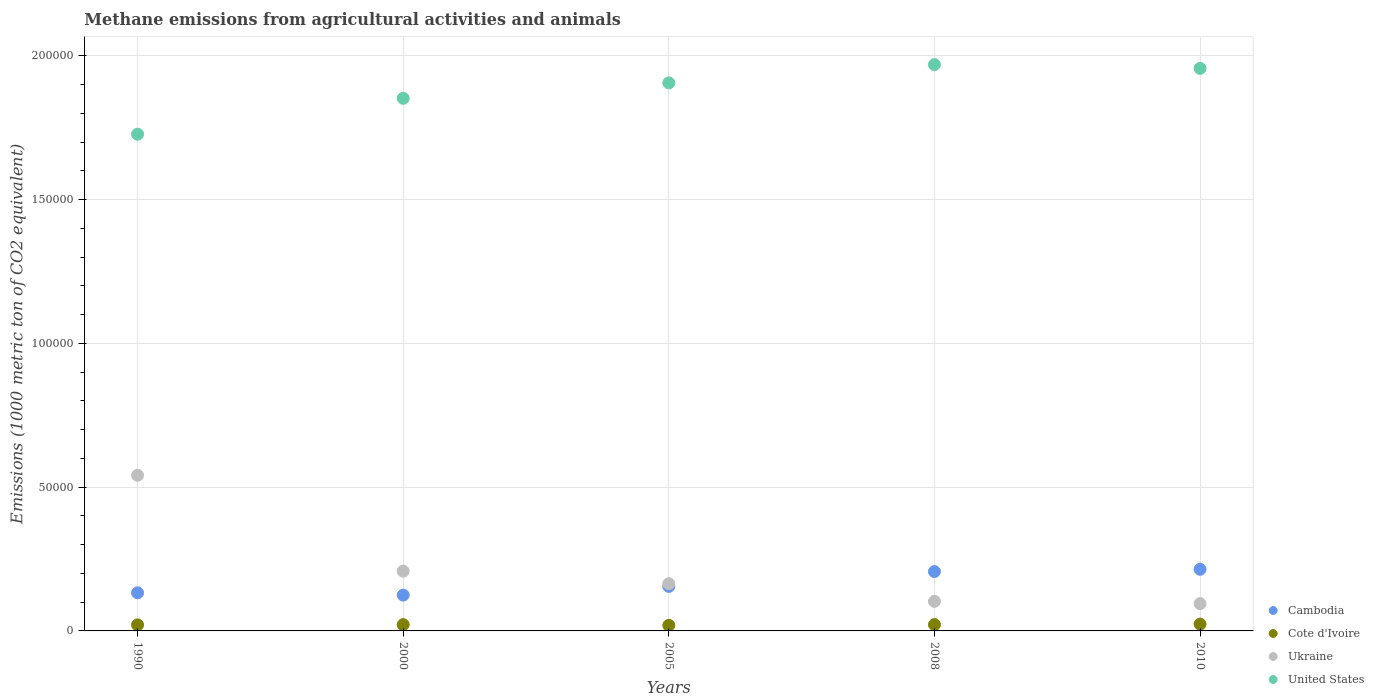How many different coloured dotlines are there?
Provide a succinct answer. 4. What is the amount of methane emitted in United States in 2005?
Your answer should be compact. 1.91e+05. Across all years, what is the maximum amount of methane emitted in Cote d'Ivoire?
Your answer should be compact. 2375.2. Across all years, what is the minimum amount of methane emitted in United States?
Provide a short and direct response. 1.73e+05. In which year was the amount of methane emitted in United States maximum?
Your answer should be compact. 2008. What is the total amount of methane emitted in United States in the graph?
Your answer should be very brief. 9.41e+05. What is the difference between the amount of methane emitted in Cambodia in 1990 and that in 2010?
Your answer should be compact. -8182.5. What is the difference between the amount of methane emitted in United States in 1990 and the amount of methane emitted in Cote d'Ivoire in 2010?
Your response must be concise. 1.70e+05. What is the average amount of methane emitted in Ukraine per year?
Keep it short and to the point. 2.22e+04. In the year 1990, what is the difference between the amount of methane emitted in Ukraine and amount of methane emitted in Cote d'Ivoire?
Make the answer very short. 5.20e+04. What is the ratio of the amount of methane emitted in Ukraine in 2000 to that in 2008?
Offer a terse response. 2.02. Is the amount of methane emitted in Cambodia in 2005 less than that in 2008?
Provide a succinct answer. Yes. What is the difference between the highest and the second highest amount of methane emitted in Cote d'Ivoire?
Keep it short and to the point. 184.9. What is the difference between the highest and the lowest amount of methane emitted in Cote d'Ivoire?
Offer a terse response. 425.1. In how many years, is the amount of methane emitted in Cambodia greater than the average amount of methane emitted in Cambodia taken over all years?
Your response must be concise. 2. Is the sum of the amount of methane emitted in Ukraine in 2008 and 2010 greater than the maximum amount of methane emitted in Cote d'Ivoire across all years?
Your answer should be very brief. Yes. Is it the case that in every year, the sum of the amount of methane emitted in Ukraine and amount of methane emitted in Cambodia  is greater than the sum of amount of methane emitted in Cote d'Ivoire and amount of methane emitted in United States?
Give a very brief answer. Yes. Is it the case that in every year, the sum of the amount of methane emitted in Cote d'Ivoire and amount of methane emitted in United States  is greater than the amount of methane emitted in Cambodia?
Your answer should be compact. Yes. Does the amount of methane emitted in United States monotonically increase over the years?
Provide a succinct answer. No. Is the amount of methane emitted in Cambodia strictly less than the amount of methane emitted in Ukraine over the years?
Your answer should be very brief. No. How many years are there in the graph?
Offer a terse response. 5. Are the values on the major ticks of Y-axis written in scientific E-notation?
Your answer should be very brief. No. Does the graph contain any zero values?
Your answer should be compact. No. Does the graph contain grids?
Your response must be concise. Yes. Where does the legend appear in the graph?
Offer a terse response. Bottom right. How many legend labels are there?
Make the answer very short. 4. How are the legend labels stacked?
Offer a very short reply. Vertical. What is the title of the graph?
Your answer should be compact. Methane emissions from agricultural activities and animals. What is the label or title of the X-axis?
Offer a terse response. Years. What is the label or title of the Y-axis?
Keep it short and to the point. Emissions (1000 metric ton of CO2 equivalent). What is the Emissions (1000 metric ton of CO2 equivalent) in Cambodia in 1990?
Provide a short and direct response. 1.32e+04. What is the Emissions (1000 metric ton of CO2 equivalent) of Cote d'Ivoire in 1990?
Offer a very short reply. 2104. What is the Emissions (1000 metric ton of CO2 equivalent) in Ukraine in 1990?
Ensure brevity in your answer.  5.41e+04. What is the Emissions (1000 metric ton of CO2 equivalent) of United States in 1990?
Your answer should be compact. 1.73e+05. What is the Emissions (1000 metric ton of CO2 equivalent) of Cambodia in 2000?
Offer a terse response. 1.25e+04. What is the Emissions (1000 metric ton of CO2 equivalent) of Cote d'Ivoire in 2000?
Give a very brief answer. 2183.1. What is the Emissions (1000 metric ton of CO2 equivalent) in Ukraine in 2000?
Provide a succinct answer. 2.08e+04. What is the Emissions (1000 metric ton of CO2 equivalent) of United States in 2000?
Provide a succinct answer. 1.85e+05. What is the Emissions (1000 metric ton of CO2 equivalent) of Cambodia in 2005?
Offer a very short reply. 1.55e+04. What is the Emissions (1000 metric ton of CO2 equivalent) in Cote d'Ivoire in 2005?
Ensure brevity in your answer.  1950.1. What is the Emissions (1000 metric ton of CO2 equivalent) in Ukraine in 2005?
Make the answer very short. 1.64e+04. What is the Emissions (1000 metric ton of CO2 equivalent) in United States in 2005?
Give a very brief answer. 1.91e+05. What is the Emissions (1000 metric ton of CO2 equivalent) in Cambodia in 2008?
Ensure brevity in your answer.  2.06e+04. What is the Emissions (1000 metric ton of CO2 equivalent) in Cote d'Ivoire in 2008?
Ensure brevity in your answer.  2190.3. What is the Emissions (1000 metric ton of CO2 equivalent) of Ukraine in 2008?
Give a very brief answer. 1.03e+04. What is the Emissions (1000 metric ton of CO2 equivalent) in United States in 2008?
Offer a very short reply. 1.97e+05. What is the Emissions (1000 metric ton of CO2 equivalent) of Cambodia in 2010?
Provide a succinct answer. 2.14e+04. What is the Emissions (1000 metric ton of CO2 equivalent) of Cote d'Ivoire in 2010?
Keep it short and to the point. 2375.2. What is the Emissions (1000 metric ton of CO2 equivalent) of Ukraine in 2010?
Give a very brief answer. 9489.8. What is the Emissions (1000 metric ton of CO2 equivalent) of United States in 2010?
Offer a very short reply. 1.96e+05. Across all years, what is the maximum Emissions (1000 metric ton of CO2 equivalent) of Cambodia?
Provide a succinct answer. 2.14e+04. Across all years, what is the maximum Emissions (1000 metric ton of CO2 equivalent) in Cote d'Ivoire?
Offer a very short reply. 2375.2. Across all years, what is the maximum Emissions (1000 metric ton of CO2 equivalent) of Ukraine?
Offer a very short reply. 5.41e+04. Across all years, what is the maximum Emissions (1000 metric ton of CO2 equivalent) of United States?
Offer a very short reply. 1.97e+05. Across all years, what is the minimum Emissions (1000 metric ton of CO2 equivalent) of Cambodia?
Your response must be concise. 1.25e+04. Across all years, what is the minimum Emissions (1000 metric ton of CO2 equivalent) in Cote d'Ivoire?
Make the answer very short. 1950.1. Across all years, what is the minimum Emissions (1000 metric ton of CO2 equivalent) of Ukraine?
Provide a succinct answer. 9489.8. Across all years, what is the minimum Emissions (1000 metric ton of CO2 equivalent) in United States?
Provide a short and direct response. 1.73e+05. What is the total Emissions (1000 metric ton of CO2 equivalent) in Cambodia in the graph?
Keep it short and to the point. 8.32e+04. What is the total Emissions (1000 metric ton of CO2 equivalent) in Cote d'Ivoire in the graph?
Offer a very short reply. 1.08e+04. What is the total Emissions (1000 metric ton of CO2 equivalent) of Ukraine in the graph?
Your response must be concise. 1.11e+05. What is the total Emissions (1000 metric ton of CO2 equivalent) of United States in the graph?
Give a very brief answer. 9.41e+05. What is the difference between the Emissions (1000 metric ton of CO2 equivalent) of Cambodia in 1990 and that in 2000?
Your response must be concise. 796.5. What is the difference between the Emissions (1000 metric ton of CO2 equivalent) in Cote d'Ivoire in 1990 and that in 2000?
Offer a very short reply. -79.1. What is the difference between the Emissions (1000 metric ton of CO2 equivalent) of Ukraine in 1990 and that in 2000?
Keep it short and to the point. 3.33e+04. What is the difference between the Emissions (1000 metric ton of CO2 equivalent) of United States in 1990 and that in 2000?
Your answer should be compact. -1.25e+04. What is the difference between the Emissions (1000 metric ton of CO2 equivalent) of Cambodia in 1990 and that in 2005?
Your answer should be very brief. -2227.1. What is the difference between the Emissions (1000 metric ton of CO2 equivalent) in Cote d'Ivoire in 1990 and that in 2005?
Your answer should be compact. 153.9. What is the difference between the Emissions (1000 metric ton of CO2 equivalent) of Ukraine in 1990 and that in 2005?
Offer a very short reply. 3.77e+04. What is the difference between the Emissions (1000 metric ton of CO2 equivalent) of United States in 1990 and that in 2005?
Provide a succinct answer. -1.78e+04. What is the difference between the Emissions (1000 metric ton of CO2 equivalent) of Cambodia in 1990 and that in 2008?
Give a very brief answer. -7382.4. What is the difference between the Emissions (1000 metric ton of CO2 equivalent) in Cote d'Ivoire in 1990 and that in 2008?
Keep it short and to the point. -86.3. What is the difference between the Emissions (1000 metric ton of CO2 equivalent) in Ukraine in 1990 and that in 2008?
Provide a short and direct response. 4.38e+04. What is the difference between the Emissions (1000 metric ton of CO2 equivalent) of United States in 1990 and that in 2008?
Offer a very short reply. -2.42e+04. What is the difference between the Emissions (1000 metric ton of CO2 equivalent) in Cambodia in 1990 and that in 2010?
Provide a succinct answer. -8182.5. What is the difference between the Emissions (1000 metric ton of CO2 equivalent) in Cote d'Ivoire in 1990 and that in 2010?
Keep it short and to the point. -271.2. What is the difference between the Emissions (1000 metric ton of CO2 equivalent) of Ukraine in 1990 and that in 2010?
Ensure brevity in your answer.  4.46e+04. What is the difference between the Emissions (1000 metric ton of CO2 equivalent) in United States in 1990 and that in 2010?
Offer a very short reply. -2.29e+04. What is the difference between the Emissions (1000 metric ton of CO2 equivalent) of Cambodia in 2000 and that in 2005?
Offer a very short reply. -3023.6. What is the difference between the Emissions (1000 metric ton of CO2 equivalent) in Cote d'Ivoire in 2000 and that in 2005?
Your answer should be compact. 233. What is the difference between the Emissions (1000 metric ton of CO2 equivalent) in Ukraine in 2000 and that in 2005?
Your answer should be compact. 4372.1. What is the difference between the Emissions (1000 metric ton of CO2 equivalent) of United States in 2000 and that in 2005?
Your answer should be compact. -5362.7. What is the difference between the Emissions (1000 metric ton of CO2 equivalent) of Cambodia in 2000 and that in 2008?
Offer a very short reply. -8178.9. What is the difference between the Emissions (1000 metric ton of CO2 equivalent) of Cote d'Ivoire in 2000 and that in 2008?
Keep it short and to the point. -7.2. What is the difference between the Emissions (1000 metric ton of CO2 equivalent) of Ukraine in 2000 and that in 2008?
Your answer should be very brief. 1.05e+04. What is the difference between the Emissions (1000 metric ton of CO2 equivalent) in United States in 2000 and that in 2008?
Keep it short and to the point. -1.17e+04. What is the difference between the Emissions (1000 metric ton of CO2 equivalent) of Cambodia in 2000 and that in 2010?
Provide a short and direct response. -8979. What is the difference between the Emissions (1000 metric ton of CO2 equivalent) in Cote d'Ivoire in 2000 and that in 2010?
Your answer should be very brief. -192.1. What is the difference between the Emissions (1000 metric ton of CO2 equivalent) in Ukraine in 2000 and that in 2010?
Make the answer very short. 1.13e+04. What is the difference between the Emissions (1000 metric ton of CO2 equivalent) in United States in 2000 and that in 2010?
Your response must be concise. -1.04e+04. What is the difference between the Emissions (1000 metric ton of CO2 equivalent) of Cambodia in 2005 and that in 2008?
Your answer should be very brief. -5155.3. What is the difference between the Emissions (1000 metric ton of CO2 equivalent) in Cote d'Ivoire in 2005 and that in 2008?
Your answer should be very brief. -240.2. What is the difference between the Emissions (1000 metric ton of CO2 equivalent) of Ukraine in 2005 and that in 2008?
Your answer should be compact. 6133.4. What is the difference between the Emissions (1000 metric ton of CO2 equivalent) in United States in 2005 and that in 2008?
Your answer should be very brief. -6353.6. What is the difference between the Emissions (1000 metric ton of CO2 equivalent) in Cambodia in 2005 and that in 2010?
Provide a succinct answer. -5955.4. What is the difference between the Emissions (1000 metric ton of CO2 equivalent) of Cote d'Ivoire in 2005 and that in 2010?
Give a very brief answer. -425.1. What is the difference between the Emissions (1000 metric ton of CO2 equivalent) of Ukraine in 2005 and that in 2010?
Your answer should be compact. 6921.6. What is the difference between the Emissions (1000 metric ton of CO2 equivalent) of United States in 2005 and that in 2010?
Your answer should be very brief. -5038.6. What is the difference between the Emissions (1000 metric ton of CO2 equivalent) in Cambodia in 2008 and that in 2010?
Make the answer very short. -800.1. What is the difference between the Emissions (1000 metric ton of CO2 equivalent) of Cote d'Ivoire in 2008 and that in 2010?
Ensure brevity in your answer.  -184.9. What is the difference between the Emissions (1000 metric ton of CO2 equivalent) of Ukraine in 2008 and that in 2010?
Provide a short and direct response. 788.2. What is the difference between the Emissions (1000 metric ton of CO2 equivalent) in United States in 2008 and that in 2010?
Your answer should be very brief. 1315. What is the difference between the Emissions (1000 metric ton of CO2 equivalent) in Cambodia in 1990 and the Emissions (1000 metric ton of CO2 equivalent) in Cote d'Ivoire in 2000?
Provide a succinct answer. 1.11e+04. What is the difference between the Emissions (1000 metric ton of CO2 equivalent) in Cambodia in 1990 and the Emissions (1000 metric ton of CO2 equivalent) in Ukraine in 2000?
Your answer should be very brief. -7533.7. What is the difference between the Emissions (1000 metric ton of CO2 equivalent) of Cambodia in 1990 and the Emissions (1000 metric ton of CO2 equivalent) of United States in 2000?
Keep it short and to the point. -1.72e+05. What is the difference between the Emissions (1000 metric ton of CO2 equivalent) of Cote d'Ivoire in 1990 and the Emissions (1000 metric ton of CO2 equivalent) of Ukraine in 2000?
Your answer should be compact. -1.87e+04. What is the difference between the Emissions (1000 metric ton of CO2 equivalent) of Cote d'Ivoire in 1990 and the Emissions (1000 metric ton of CO2 equivalent) of United States in 2000?
Provide a succinct answer. -1.83e+05. What is the difference between the Emissions (1000 metric ton of CO2 equivalent) of Ukraine in 1990 and the Emissions (1000 metric ton of CO2 equivalent) of United States in 2000?
Provide a short and direct response. -1.31e+05. What is the difference between the Emissions (1000 metric ton of CO2 equivalent) in Cambodia in 1990 and the Emissions (1000 metric ton of CO2 equivalent) in Cote d'Ivoire in 2005?
Offer a very short reply. 1.13e+04. What is the difference between the Emissions (1000 metric ton of CO2 equivalent) in Cambodia in 1990 and the Emissions (1000 metric ton of CO2 equivalent) in Ukraine in 2005?
Provide a succinct answer. -3161.6. What is the difference between the Emissions (1000 metric ton of CO2 equivalent) in Cambodia in 1990 and the Emissions (1000 metric ton of CO2 equivalent) in United States in 2005?
Your answer should be compact. -1.77e+05. What is the difference between the Emissions (1000 metric ton of CO2 equivalent) in Cote d'Ivoire in 1990 and the Emissions (1000 metric ton of CO2 equivalent) in Ukraine in 2005?
Provide a short and direct response. -1.43e+04. What is the difference between the Emissions (1000 metric ton of CO2 equivalent) of Cote d'Ivoire in 1990 and the Emissions (1000 metric ton of CO2 equivalent) of United States in 2005?
Your response must be concise. -1.88e+05. What is the difference between the Emissions (1000 metric ton of CO2 equivalent) in Ukraine in 1990 and the Emissions (1000 metric ton of CO2 equivalent) in United States in 2005?
Give a very brief answer. -1.36e+05. What is the difference between the Emissions (1000 metric ton of CO2 equivalent) in Cambodia in 1990 and the Emissions (1000 metric ton of CO2 equivalent) in Cote d'Ivoire in 2008?
Make the answer very short. 1.11e+04. What is the difference between the Emissions (1000 metric ton of CO2 equivalent) in Cambodia in 1990 and the Emissions (1000 metric ton of CO2 equivalent) in Ukraine in 2008?
Provide a succinct answer. 2971.8. What is the difference between the Emissions (1000 metric ton of CO2 equivalent) in Cambodia in 1990 and the Emissions (1000 metric ton of CO2 equivalent) in United States in 2008?
Keep it short and to the point. -1.84e+05. What is the difference between the Emissions (1000 metric ton of CO2 equivalent) of Cote d'Ivoire in 1990 and the Emissions (1000 metric ton of CO2 equivalent) of Ukraine in 2008?
Offer a very short reply. -8174. What is the difference between the Emissions (1000 metric ton of CO2 equivalent) of Cote d'Ivoire in 1990 and the Emissions (1000 metric ton of CO2 equivalent) of United States in 2008?
Offer a very short reply. -1.95e+05. What is the difference between the Emissions (1000 metric ton of CO2 equivalent) in Ukraine in 1990 and the Emissions (1000 metric ton of CO2 equivalent) in United States in 2008?
Keep it short and to the point. -1.43e+05. What is the difference between the Emissions (1000 metric ton of CO2 equivalent) of Cambodia in 1990 and the Emissions (1000 metric ton of CO2 equivalent) of Cote d'Ivoire in 2010?
Provide a succinct answer. 1.09e+04. What is the difference between the Emissions (1000 metric ton of CO2 equivalent) in Cambodia in 1990 and the Emissions (1000 metric ton of CO2 equivalent) in Ukraine in 2010?
Ensure brevity in your answer.  3760. What is the difference between the Emissions (1000 metric ton of CO2 equivalent) in Cambodia in 1990 and the Emissions (1000 metric ton of CO2 equivalent) in United States in 2010?
Offer a terse response. -1.82e+05. What is the difference between the Emissions (1000 metric ton of CO2 equivalent) of Cote d'Ivoire in 1990 and the Emissions (1000 metric ton of CO2 equivalent) of Ukraine in 2010?
Give a very brief answer. -7385.8. What is the difference between the Emissions (1000 metric ton of CO2 equivalent) in Cote d'Ivoire in 1990 and the Emissions (1000 metric ton of CO2 equivalent) in United States in 2010?
Your answer should be very brief. -1.93e+05. What is the difference between the Emissions (1000 metric ton of CO2 equivalent) in Ukraine in 1990 and the Emissions (1000 metric ton of CO2 equivalent) in United States in 2010?
Your answer should be very brief. -1.41e+05. What is the difference between the Emissions (1000 metric ton of CO2 equivalent) of Cambodia in 2000 and the Emissions (1000 metric ton of CO2 equivalent) of Cote d'Ivoire in 2005?
Give a very brief answer. 1.05e+04. What is the difference between the Emissions (1000 metric ton of CO2 equivalent) in Cambodia in 2000 and the Emissions (1000 metric ton of CO2 equivalent) in Ukraine in 2005?
Offer a terse response. -3958.1. What is the difference between the Emissions (1000 metric ton of CO2 equivalent) of Cambodia in 2000 and the Emissions (1000 metric ton of CO2 equivalent) of United States in 2005?
Your answer should be compact. -1.78e+05. What is the difference between the Emissions (1000 metric ton of CO2 equivalent) of Cote d'Ivoire in 2000 and the Emissions (1000 metric ton of CO2 equivalent) of Ukraine in 2005?
Your response must be concise. -1.42e+04. What is the difference between the Emissions (1000 metric ton of CO2 equivalent) in Cote d'Ivoire in 2000 and the Emissions (1000 metric ton of CO2 equivalent) in United States in 2005?
Your response must be concise. -1.88e+05. What is the difference between the Emissions (1000 metric ton of CO2 equivalent) of Ukraine in 2000 and the Emissions (1000 metric ton of CO2 equivalent) of United States in 2005?
Provide a short and direct response. -1.70e+05. What is the difference between the Emissions (1000 metric ton of CO2 equivalent) of Cambodia in 2000 and the Emissions (1000 metric ton of CO2 equivalent) of Cote d'Ivoire in 2008?
Your response must be concise. 1.03e+04. What is the difference between the Emissions (1000 metric ton of CO2 equivalent) in Cambodia in 2000 and the Emissions (1000 metric ton of CO2 equivalent) in Ukraine in 2008?
Give a very brief answer. 2175.3. What is the difference between the Emissions (1000 metric ton of CO2 equivalent) of Cambodia in 2000 and the Emissions (1000 metric ton of CO2 equivalent) of United States in 2008?
Provide a succinct answer. -1.84e+05. What is the difference between the Emissions (1000 metric ton of CO2 equivalent) in Cote d'Ivoire in 2000 and the Emissions (1000 metric ton of CO2 equivalent) in Ukraine in 2008?
Your answer should be compact. -8094.9. What is the difference between the Emissions (1000 metric ton of CO2 equivalent) in Cote d'Ivoire in 2000 and the Emissions (1000 metric ton of CO2 equivalent) in United States in 2008?
Your answer should be compact. -1.95e+05. What is the difference between the Emissions (1000 metric ton of CO2 equivalent) of Ukraine in 2000 and the Emissions (1000 metric ton of CO2 equivalent) of United States in 2008?
Give a very brief answer. -1.76e+05. What is the difference between the Emissions (1000 metric ton of CO2 equivalent) in Cambodia in 2000 and the Emissions (1000 metric ton of CO2 equivalent) in Cote d'Ivoire in 2010?
Offer a terse response. 1.01e+04. What is the difference between the Emissions (1000 metric ton of CO2 equivalent) of Cambodia in 2000 and the Emissions (1000 metric ton of CO2 equivalent) of Ukraine in 2010?
Offer a very short reply. 2963.5. What is the difference between the Emissions (1000 metric ton of CO2 equivalent) in Cambodia in 2000 and the Emissions (1000 metric ton of CO2 equivalent) in United States in 2010?
Ensure brevity in your answer.  -1.83e+05. What is the difference between the Emissions (1000 metric ton of CO2 equivalent) of Cote d'Ivoire in 2000 and the Emissions (1000 metric ton of CO2 equivalent) of Ukraine in 2010?
Ensure brevity in your answer.  -7306.7. What is the difference between the Emissions (1000 metric ton of CO2 equivalent) in Cote d'Ivoire in 2000 and the Emissions (1000 metric ton of CO2 equivalent) in United States in 2010?
Your answer should be very brief. -1.93e+05. What is the difference between the Emissions (1000 metric ton of CO2 equivalent) in Ukraine in 2000 and the Emissions (1000 metric ton of CO2 equivalent) in United States in 2010?
Make the answer very short. -1.75e+05. What is the difference between the Emissions (1000 metric ton of CO2 equivalent) of Cambodia in 2005 and the Emissions (1000 metric ton of CO2 equivalent) of Cote d'Ivoire in 2008?
Make the answer very short. 1.33e+04. What is the difference between the Emissions (1000 metric ton of CO2 equivalent) of Cambodia in 2005 and the Emissions (1000 metric ton of CO2 equivalent) of Ukraine in 2008?
Provide a short and direct response. 5198.9. What is the difference between the Emissions (1000 metric ton of CO2 equivalent) of Cambodia in 2005 and the Emissions (1000 metric ton of CO2 equivalent) of United States in 2008?
Your answer should be very brief. -1.81e+05. What is the difference between the Emissions (1000 metric ton of CO2 equivalent) in Cote d'Ivoire in 2005 and the Emissions (1000 metric ton of CO2 equivalent) in Ukraine in 2008?
Your response must be concise. -8327.9. What is the difference between the Emissions (1000 metric ton of CO2 equivalent) in Cote d'Ivoire in 2005 and the Emissions (1000 metric ton of CO2 equivalent) in United States in 2008?
Your answer should be very brief. -1.95e+05. What is the difference between the Emissions (1000 metric ton of CO2 equivalent) of Ukraine in 2005 and the Emissions (1000 metric ton of CO2 equivalent) of United States in 2008?
Keep it short and to the point. -1.81e+05. What is the difference between the Emissions (1000 metric ton of CO2 equivalent) in Cambodia in 2005 and the Emissions (1000 metric ton of CO2 equivalent) in Cote d'Ivoire in 2010?
Offer a very short reply. 1.31e+04. What is the difference between the Emissions (1000 metric ton of CO2 equivalent) of Cambodia in 2005 and the Emissions (1000 metric ton of CO2 equivalent) of Ukraine in 2010?
Your answer should be very brief. 5987.1. What is the difference between the Emissions (1000 metric ton of CO2 equivalent) of Cambodia in 2005 and the Emissions (1000 metric ton of CO2 equivalent) of United States in 2010?
Keep it short and to the point. -1.80e+05. What is the difference between the Emissions (1000 metric ton of CO2 equivalent) of Cote d'Ivoire in 2005 and the Emissions (1000 metric ton of CO2 equivalent) of Ukraine in 2010?
Offer a very short reply. -7539.7. What is the difference between the Emissions (1000 metric ton of CO2 equivalent) of Cote d'Ivoire in 2005 and the Emissions (1000 metric ton of CO2 equivalent) of United States in 2010?
Ensure brevity in your answer.  -1.94e+05. What is the difference between the Emissions (1000 metric ton of CO2 equivalent) in Ukraine in 2005 and the Emissions (1000 metric ton of CO2 equivalent) in United States in 2010?
Offer a very short reply. -1.79e+05. What is the difference between the Emissions (1000 metric ton of CO2 equivalent) in Cambodia in 2008 and the Emissions (1000 metric ton of CO2 equivalent) in Cote d'Ivoire in 2010?
Keep it short and to the point. 1.83e+04. What is the difference between the Emissions (1000 metric ton of CO2 equivalent) in Cambodia in 2008 and the Emissions (1000 metric ton of CO2 equivalent) in Ukraine in 2010?
Your answer should be very brief. 1.11e+04. What is the difference between the Emissions (1000 metric ton of CO2 equivalent) of Cambodia in 2008 and the Emissions (1000 metric ton of CO2 equivalent) of United States in 2010?
Provide a short and direct response. -1.75e+05. What is the difference between the Emissions (1000 metric ton of CO2 equivalent) of Cote d'Ivoire in 2008 and the Emissions (1000 metric ton of CO2 equivalent) of Ukraine in 2010?
Keep it short and to the point. -7299.5. What is the difference between the Emissions (1000 metric ton of CO2 equivalent) of Cote d'Ivoire in 2008 and the Emissions (1000 metric ton of CO2 equivalent) of United States in 2010?
Keep it short and to the point. -1.93e+05. What is the difference between the Emissions (1000 metric ton of CO2 equivalent) in Ukraine in 2008 and the Emissions (1000 metric ton of CO2 equivalent) in United States in 2010?
Keep it short and to the point. -1.85e+05. What is the average Emissions (1000 metric ton of CO2 equivalent) of Cambodia per year?
Your answer should be compact. 1.66e+04. What is the average Emissions (1000 metric ton of CO2 equivalent) of Cote d'Ivoire per year?
Provide a short and direct response. 2160.54. What is the average Emissions (1000 metric ton of CO2 equivalent) in Ukraine per year?
Keep it short and to the point. 2.22e+04. What is the average Emissions (1000 metric ton of CO2 equivalent) in United States per year?
Keep it short and to the point. 1.88e+05. In the year 1990, what is the difference between the Emissions (1000 metric ton of CO2 equivalent) of Cambodia and Emissions (1000 metric ton of CO2 equivalent) of Cote d'Ivoire?
Offer a very short reply. 1.11e+04. In the year 1990, what is the difference between the Emissions (1000 metric ton of CO2 equivalent) in Cambodia and Emissions (1000 metric ton of CO2 equivalent) in Ukraine?
Provide a succinct answer. -4.09e+04. In the year 1990, what is the difference between the Emissions (1000 metric ton of CO2 equivalent) of Cambodia and Emissions (1000 metric ton of CO2 equivalent) of United States?
Make the answer very short. -1.59e+05. In the year 1990, what is the difference between the Emissions (1000 metric ton of CO2 equivalent) of Cote d'Ivoire and Emissions (1000 metric ton of CO2 equivalent) of Ukraine?
Offer a terse response. -5.20e+04. In the year 1990, what is the difference between the Emissions (1000 metric ton of CO2 equivalent) of Cote d'Ivoire and Emissions (1000 metric ton of CO2 equivalent) of United States?
Your answer should be compact. -1.71e+05. In the year 1990, what is the difference between the Emissions (1000 metric ton of CO2 equivalent) of Ukraine and Emissions (1000 metric ton of CO2 equivalent) of United States?
Make the answer very short. -1.19e+05. In the year 2000, what is the difference between the Emissions (1000 metric ton of CO2 equivalent) of Cambodia and Emissions (1000 metric ton of CO2 equivalent) of Cote d'Ivoire?
Your answer should be compact. 1.03e+04. In the year 2000, what is the difference between the Emissions (1000 metric ton of CO2 equivalent) in Cambodia and Emissions (1000 metric ton of CO2 equivalent) in Ukraine?
Offer a very short reply. -8330.2. In the year 2000, what is the difference between the Emissions (1000 metric ton of CO2 equivalent) of Cambodia and Emissions (1000 metric ton of CO2 equivalent) of United States?
Your response must be concise. -1.73e+05. In the year 2000, what is the difference between the Emissions (1000 metric ton of CO2 equivalent) in Cote d'Ivoire and Emissions (1000 metric ton of CO2 equivalent) in Ukraine?
Make the answer very short. -1.86e+04. In the year 2000, what is the difference between the Emissions (1000 metric ton of CO2 equivalent) in Cote d'Ivoire and Emissions (1000 metric ton of CO2 equivalent) in United States?
Keep it short and to the point. -1.83e+05. In the year 2000, what is the difference between the Emissions (1000 metric ton of CO2 equivalent) in Ukraine and Emissions (1000 metric ton of CO2 equivalent) in United States?
Make the answer very short. -1.64e+05. In the year 2005, what is the difference between the Emissions (1000 metric ton of CO2 equivalent) in Cambodia and Emissions (1000 metric ton of CO2 equivalent) in Cote d'Ivoire?
Offer a very short reply. 1.35e+04. In the year 2005, what is the difference between the Emissions (1000 metric ton of CO2 equivalent) of Cambodia and Emissions (1000 metric ton of CO2 equivalent) of Ukraine?
Your response must be concise. -934.5. In the year 2005, what is the difference between the Emissions (1000 metric ton of CO2 equivalent) in Cambodia and Emissions (1000 metric ton of CO2 equivalent) in United States?
Offer a terse response. -1.75e+05. In the year 2005, what is the difference between the Emissions (1000 metric ton of CO2 equivalent) of Cote d'Ivoire and Emissions (1000 metric ton of CO2 equivalent) of Ukraine?
Give a very brief answer. -1.45e+04. In the year 2005, what is the difference between the Emissions (1000 metric ton of CO2 equivalent) in Cote d'Ivoire and Emissions (1000 metric ton of CO2 equivalent) in United States?
Your response must be concise. -1.89e+05. In the year 2005, what is the difference between the Emissions (1000 metric ton of CO2 equivalent) in Ukraine and Emissions (1000 metric ton of CO2 equivalent) in United States?
Provide a short and direct response. -1.74e+05. In the year 2008, what is the difference between the Emissions (1000 metric ton of CO2 equivalent) in Cambodia and Emissions (1000 metric ton of CO2 equivalent) in Cote d'Ivoire?
Give a very brief answer. 1.84e+04. In the year 2008, what is the difference between the Emissions (1000 metric ton of CO2 equivalent) of Cambodia and Emissions (1000 metric ton of CO2 equivalent) of Ukraine?
Provide a short and direct response. 1.04e+04. In the year 2008, what is the difference between the Emissions (1000 metric ton of CO2 equivalent) in Cambodia and Emissions (1000 metric ton of CO2 equivalent) in United States?
Your response must be concise. -1.76e+05. In the year 2008, what is the difference between the Emissions (1000 metric ton of CO2 equivalent) of Cote d'Ivoire and Emissions (1000 metric ton of CO2 equivalent) of Ukraine?
Your answer should be very brief. -8087.7. In the year 2008, what is the difference between the Emissions (1000 metric ton of CO2 equivalent) in Cote d'Ivoire and Emissions (1000 metric ton of CO2 equivalent) in United States?
Keep it short and to the point. -1.95e+05. In the year 2008, what is the difference between the Emissions (1000 metric ton of CO2 equivalent) of Ukraine and Emissions (1000 metric ton of CO2 equivalent) of United States?
Provide a succinct answer. -1.87e+05. In the year 2010, what is the difference between the Emissions (1000 metric ton of CO2 equivalent) in Cambodia and Emissions (1000 metric ton of CO2 equivalent) in Cote d'Ivoire?
Ensure brevity in your answer.  1.91e+04. In the year 2010, what is the difference between the Emissions (1000 metric ton of CO2 equivalent) of Cambodia and Emissions (1000 metric ton of CO2 equivalent) of Ukraine?
Make the answer very short. 1.19e+04. In the year 2010, what is the difference between the Emissions (1000 metric ton of CO2 equivalent) of Cambodia and Emissions (1000 metric ton of CO2 equivalent) of United States?
Provide a short and direct response. -1.74e+05. In the year 2010, what is the difference between the Emissions (1000 metric ton of CO2 equivalent) in Cote d'Ivoire and Emissions (1000 metric ton of CO2 equivalent) in Ukraine?
Offer a terse response. -7114.6. In the year 2010, what is the difference between the Emissions (1000 metric ton of CO2 equivalent) of Cote d'Ivoire and Emissions (1000 metric ton of CO2 equivalent) of United States?
Offer a terse response. -1.93e+05. In the year 2010, what is the difference between the Emissions (1000 metric ton of CO2 equivalent) in Ukraine and Emissions (1000 metric ton of CO2 equivalent) in United States?
Offer a terse response. -1.86e+05. What is the ratio of the Emissions (1000 metric ton of CO2 equivalent) of Cambodia in 1990 to that in 2000?
Provide a short and direct response. 1.06. What is the ratio of the Emissions (1000 metric ton of CO2 equivalent) of Cote d'Ivoire in 1990 to that in 2000?
Your answer should be very brief. 0.96. What is the ratio of the Emissions (1000 metric ton of CO2 equivalent) in Ukraine in 1990 to that in 2000?
Your answer should be compact. 2.6. What is the ratio of the Emissions (1000 metric ton of CO2 equivalent) in United States in 1990 to that in 2000?
Ensure brevity in your answer.  0.93. What is the ratio of the Emissions (1000 metric ton of CO2 equivalent) in Cambodia in 1990 to that in 2005?
Give a very brief answer. 0.86. What is the ratio of the Emissions (1000 metric ton of CO2 equivalent) in Cote d'Ivoire in 1990 to that in 2005?
Your answer should be very brief. 1.08. What is the ratio of the Emissions (1000 metric ton of CO2 equivalent) in Ukraine in 1990 to that in 2005?
Ensure brevity in your answer.  3.3. What is the ratio of the Emissions (1000 metric ton of CO2 equivalent) of United States in 1990 to that in 2005?
Keep it short and to the point. 0.91. What is the ratio of the Emissions (1000 metric ton of CO2 equivalent) in Cambodia in 1990 to that in 2008?
Provide a succinct answer. 0.64. What is the ratio of the Emissions (1000 metric ton of CO2 equivalent) of Cote d'Ivoire in 1990 to that in 2008?
Ensure brevity in your answer.  0.96. What is the ratio of the Emissions (1000 metric ton of CO2 equivalent) of Ukraine in 1990 to that in 2008?
Your answer should be very brief. 5.27. What is the ratio of the Emissions (1000 metric ton of CO2 equivalent) of United States in 1990 to that in 2008?
Make the answer very short. 0.88. What is the ratio of the Emissions (1000 metric ton of CO2 equivalent) in Cambodia in 1990 to that in 2010?
Offer a terse response. 0.62. What is the ratio of the Emissions (1000 metric ton of CO2 equivalent) of Cote d'Ivoire in 1990 to that in 2010?
Give a very brief answer. 0.89. What is the ratio of the Emissions (1000 metric ton of CO2 equivalent) of Ukraine in 1990 to that in 2010?
Offer a very short reply. 5.7. What is the ratio of the Emissions (1000 metric ton of CO2 equivalent) in United States in 1990 to that in 2010?
Provide a succinct answer. 0.88. What is the ratio of the Emissions (1000 metric ton of CO2 equivalent) of Cambodia in 2000 to that in 2005?
Make the answer very short. 0.8. What is the ratio of the Emissions (1000 metric ton of CO2 equivalent) of Cote d'Ivoire in 2000 to that in 2005?
Give a very brief answer. 1.12. What is the ratio of the Emissions (1000 metric ton of CO2 equivalent) of Ukraine in 2000 to that in 2005?
Your response must be concise. 1.27. What is the ratio of the Emissions (1000 metric ton of CO2 equivalent) in United States in 2000 to that in 2005?
Your answer should be very brief. 0.97. What is the ratio of the Emissions (1000 metric ton of CO2 equivalent) in Cambodia in 2000 to that in 2008?
Your answer should be very brief. 0.6. What is the ratio of the Emissions (1000 metric ton of CO2 equivalent) in Cote d'Ivoire in 2000 to that in 2008?
Give a very brief answer. 1. What is the ratio of the Emissions (1000 metric ton of CO2 equivalent) in Ukraine in 2000 to that in 2008?
Keep it short and to the point. 2.02. What is the ratio of the Emissions (1000 metric ton of CO2 equivalent) in United States in 2000 to that in 2008?
Offer a terse response. 0.94. What is the ratio of the Emissions (1000 metric ton of CO2 equivalent) of Cambodia in 2000 to that in 2010?
Ensure brevity in your answer.  0.58. What is the ratio of the Emissions (1000 metric ton of CO2 equivalent) of Cote d'Ivoire in 2000 to that in 2010?
Your answer should be very brief. 0.92. What is the ratio of the Emissions (1000 metric ton of CO2 equivalent) in Ukraine in 2000 to that in 2010?
Your answer should be very brief. 2.19. What is the ratio of the Emissions (1000 metric ton of CO2 equivalent) in United States in 2000 to that in 2010?
Make the answer very short. 0.95. What is the ratio of the Emissions (1000 metric ton of CO2 equivalent) of Cambodia in 2005 to that in 2008?
Give a very brief answer. 0.75. What is the ratio of the Emissions (1000 metric ton of CO2 equivalent) of Cote d'Ivoire in 2005 to that in 2008?
Offer a very short reply. 0.89. What is the ratio of the Emissions (1000 metric ton of CO2 equivalent) of Ukraine in 2005 to that in 2008?
Your answer should be compact. 1.6. What is the ratio of the Emissions (1000 metric ton of CO2 equivalent) in Cambodia in 2005 to that in 2010?
Provide a succinct answer. 0.72. What is the ratio of the Emissions (1000 metric ton of CO2 equivalent) of Cote d'Ivoire in 2005 to that in 2010?
Your answer should be compact. 0.82. What is the ratio of the Emissions (1000 metric ton of CO2 equivalent) of Ukraine in 2005 to that in 2010?
Offer a very short reply. 1.73. What is the ratio of the Emissions (1000 metric ton of CO2 equivalent) in United States in 2005 to that in 2010?
Provide a succinct answer. 0.97. What is the ratio of the Emissions (1000 metric ton of CO2 equivalent) in Cambodia in 2008 to that in 2010?
Your answer should be compact. 0.96. What is the ratio of the Emissions (1000 metric ton of CO2 equivalent) in Cote d'Ivoire in 2008 to that in 2010?
Provide a succinct answer. 0.92. What is the ratio of the Emissions (1000 metric ton of CO2 equivalent) in Ukraine in 2008 to that in 2010?
Your answer should be compact. 1.08. What is the ratio of the Emissions (1000 metric ton of CO2 equivalent) in United States in 2008 to that in 2010?
Your answer should be very brief. 1.01. What is the difference between the highest and the second highest Emissions (1000 metric ton of CO2 equivalent) of Cambodia?
Make the answer very short. 800.1. What is the difference between the highest and the second highest Emissions (1000 metric ton of CO2 equivalent) in Cote d'Ivoire?
Provide a succinct answer. 184.9. What is the difference between the highest and the second highest Emissions (1000 metric ton of CO2 equivalent) in Ukraine?
Offer a very short reply. 3.33e+04. What is the difference between the highest and the second highest Emissions (1000 metric ton of CO2 equivalent) of United States?
Your answer should be compact. 1315. What is the difference between the highest and the lowest Emissions (1000 metric ton of CO2 equivalent) in Cambodia?
Your answer should be compact. 8979. What is the difference between the highest and the lowest Emissions (1000 metric ton of CO2 equivalent) of Cote d'Ivoire?
Keep it short and to the point. 425.1. What is the difference between the highest and the lowest Emissions (1000 metric ton of CO2 equivalent) of Ukraine?
Make the answer very short. 4.46e+04. What is the difference between the highest and the lowest Emissions (1000 metric ton of CO2 equivalent) in United States?
Provide a succinct answer. 2.42e+04. 